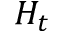<formula> <loc_0><loc_0><loc_500><loc_500>H _ { t }</formula> 